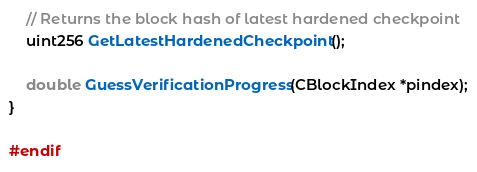Convert code to text. <code><loc_0><loc_0><loc_500><loc_500><_C_>
    // Returns the block hash of latest hardened checkpoint
    uint256 GetLatestHardenedCheckpoint();

    double GuessVerificationProgress(CBlockIndex *pindex);
}

#endif
</code> 